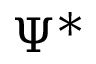<formula> <loc_0><loc_0><loc_500><loc_500>\Psi ^ { * }</formula> 